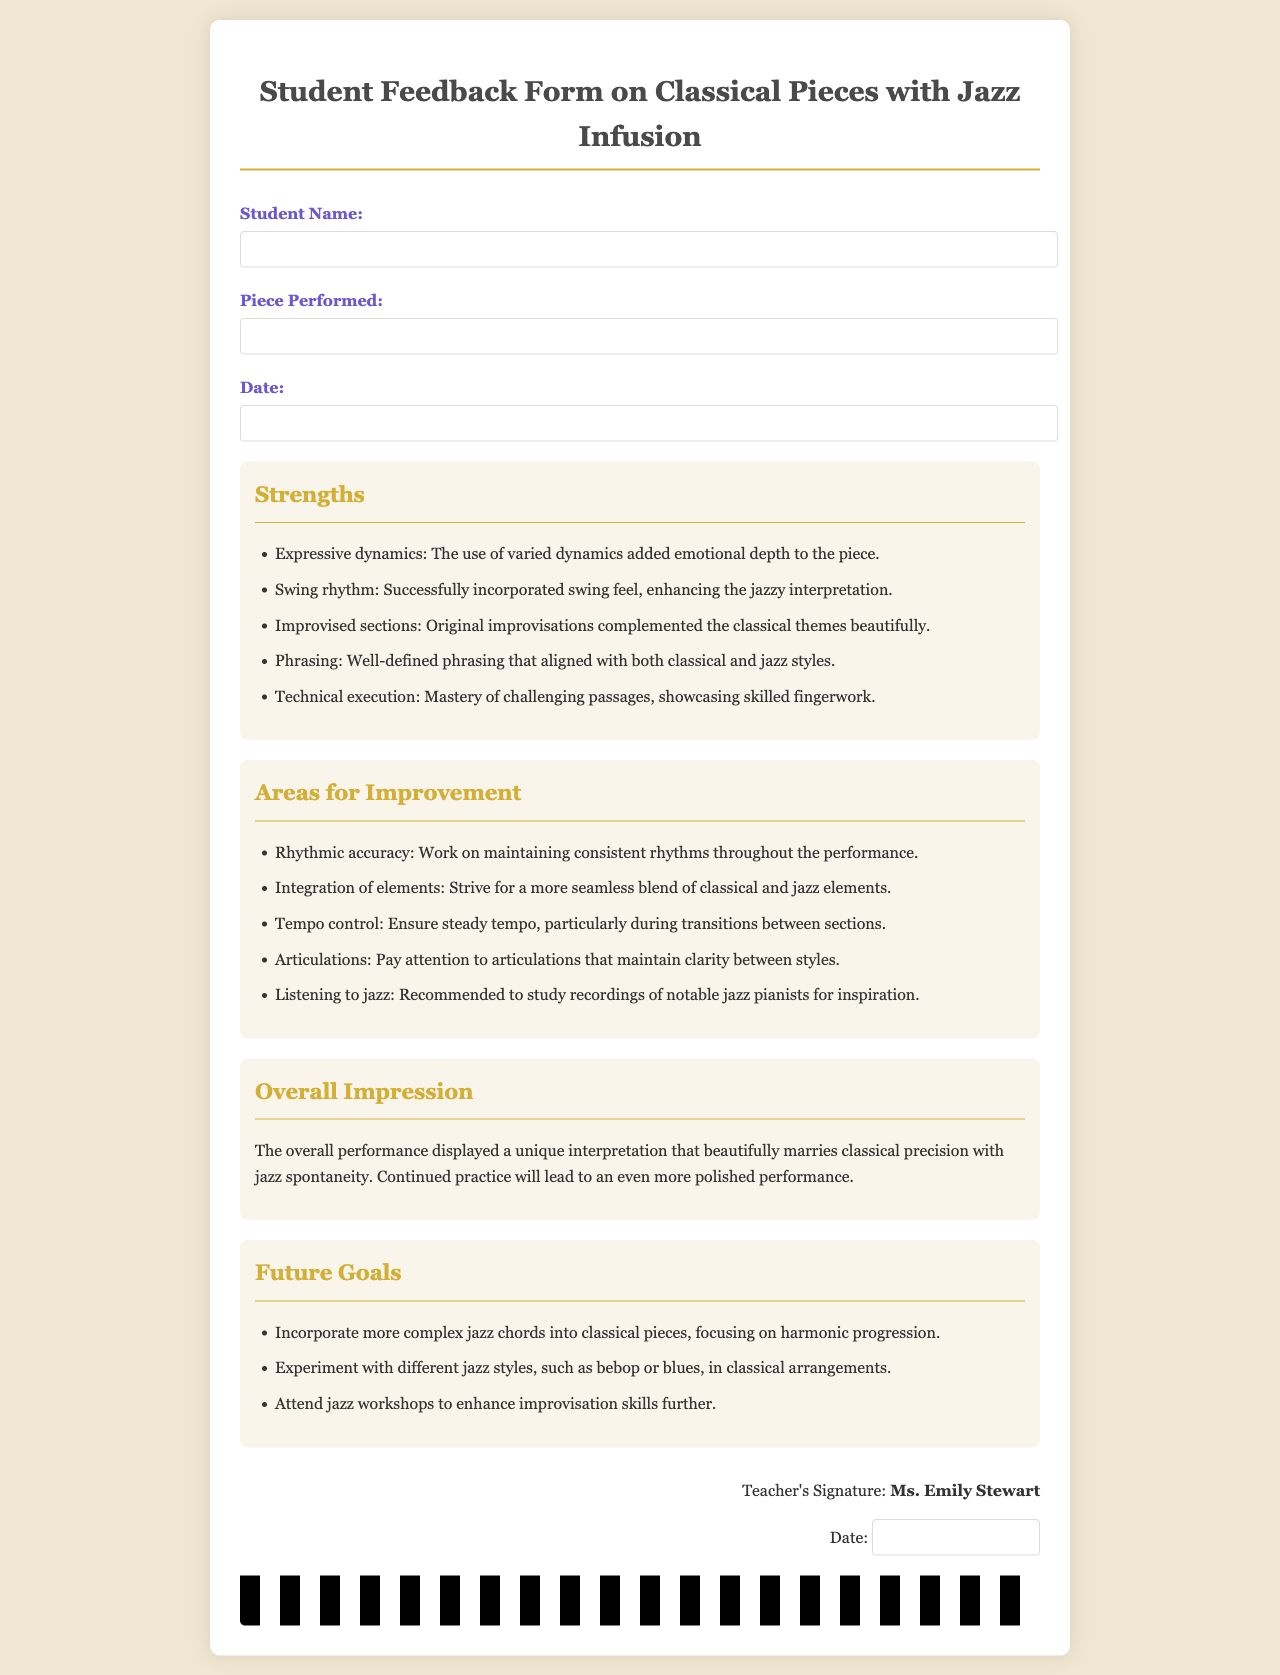What is the title of the document? The title of the document is provided at the very top of the rendered form, specifying its purpose.
Answer: Student Feedback Form on Classical Pieces with Jazz Infusion Who signed the feedback form? The signature section at the bottom of the document indicates the teacher who provided the feedback.
Answer: Ms. Emily Stewart What date is included in the feedback form for the student? The document contains a specific section where the date can be filled in, typically associated with when the performance occurred.
Answer: [Blank for date entry] What are two strengths mentioned in the feedback? The strengths are listed in a bullet format within the document, identifying key positive aspects of the performance.
Answer: Expressive dynamics, Swing rhythm What is one area for improvement suggested for the student? The areas for improvement are also listed in a bullet format within the document, detailing suggestions for enhancement.
Answer: Rhythmic accuracy What is the overall impression of the student’s performance? A summary provided in the document encapsulates the teacher's appreciation of the student's interpretation.
Answer: The overall performance displayed a unique interpretation that beautifully marries classical precision with jazz spontaneity What is one future goal noted in the document? Future goals are outlined in a bulleted list, specifying aspirations for the student's continued growth as a pianist.
Answer: Incorporate more complex jazz chords into classical pieces When did the student perform the piece? The document has a space dedicated to indicating the performance date, associated with the feedback received.
Answer: [Blank for date entry] 